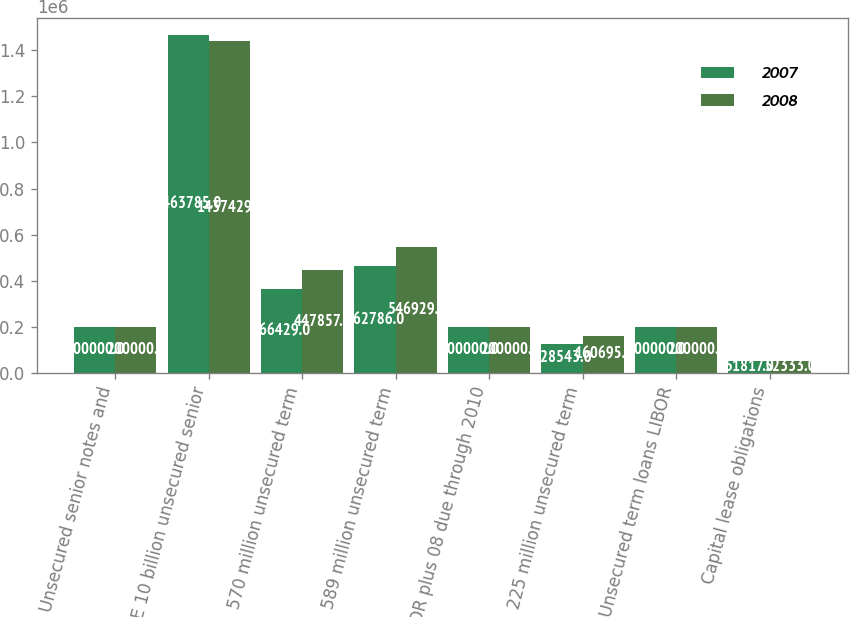<chart> <loc_0><loc_0><loc_500><loc_500><stacked_bar_chart><ecel><fcel>Unsecured senior notes and<fcel>E 10 billion unsecured senior<fcel>570 million unsecured term<fcel>589 million unsecured term<fcel>LIBOR plus 08 due through 2010<fcel>225 million unsecured term<fcel>Unsecured term loans LIBOR<fcel>Capital lease obligations<nl><fcel>2007<fcel>200000<fcel>1.46378e+06<fcel>366429<fcel>462786<fcel>200000<fcel>128543<fcel>200000<fcel>51817<nl><fcel>2008<fcel>200000<fcel>1.43743e+06<fcel>447857<fcel>546929<fcel>200000<fcel>160695<fcel>200000<fcel>52333<nl></chart> 